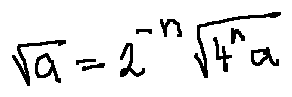Convert formula to latex. <formula><loc_0><loc_0><loc_500><loc_500>\sqrt { a } = 2 ^ { - n } \sqrt { 4 ^ { n } a }</formula> 